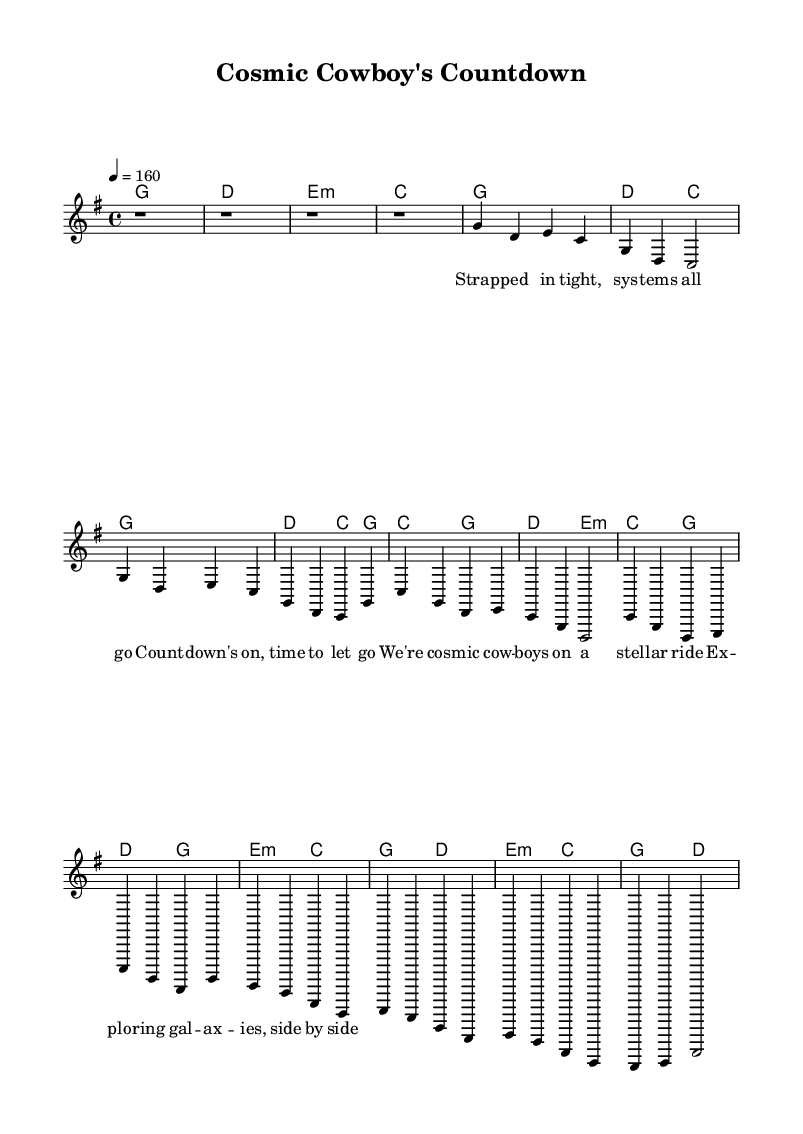What is the key signature of this music? The key signature is G major, which has one sharp (F#). This can be determined by identifying the key signature mark at the beginning of the staff.
Answer: G major What time signature is used in this piece? The time signature is 4/4, indicating that each measure contains four beats, and the quarter note receives one beat. This information is located at the beginning of the sheet music, right after the key signature.
Answer: 4/4 What is the tempo marking for this piece? The tempo marking is 160 beats per minute, indicated by the tempo text "4 = 160" at the beginning of the piece. This means the piece is meant to be played at a brisk pace.
Answer: 160 How many measures are in the verse section? There are 4 measures in the verse section, which can be counted by looking at the melody line and counting the segments labeled "Verse." Each segment contains a specific number of beats that fills a measure.
Answer: 4 What is the structure of the song? The structure consists of an intro, verse, chorus, and bridge, based on the layout of the sections presented in the sheet music. Each section represents a distinct part of the song, following an arrangement typical for a country rock anthem.
Answer: Intro, Verse, Chorus, Bridge What is the mood conveyed by the tempo and rhythm? The mood is energetic and upbeat due to the fast tempo (160 BPM) and the lively 4/4 meter, which is typical of country rock anthems that aim to evoke a sense of excitement and adventure, especially related to themes of exploration.
Answer: Energetic What type of instrumentation is likely indicated by the score? The instrumentation indicated is likely guitar (for chords and lead melody) and possibly bass for supporting harmonies, as these are standard instruments used in country rock music. The presence of chord symbols reinforces the likelihood of guitar accompaniment.
Answer: Guitar 